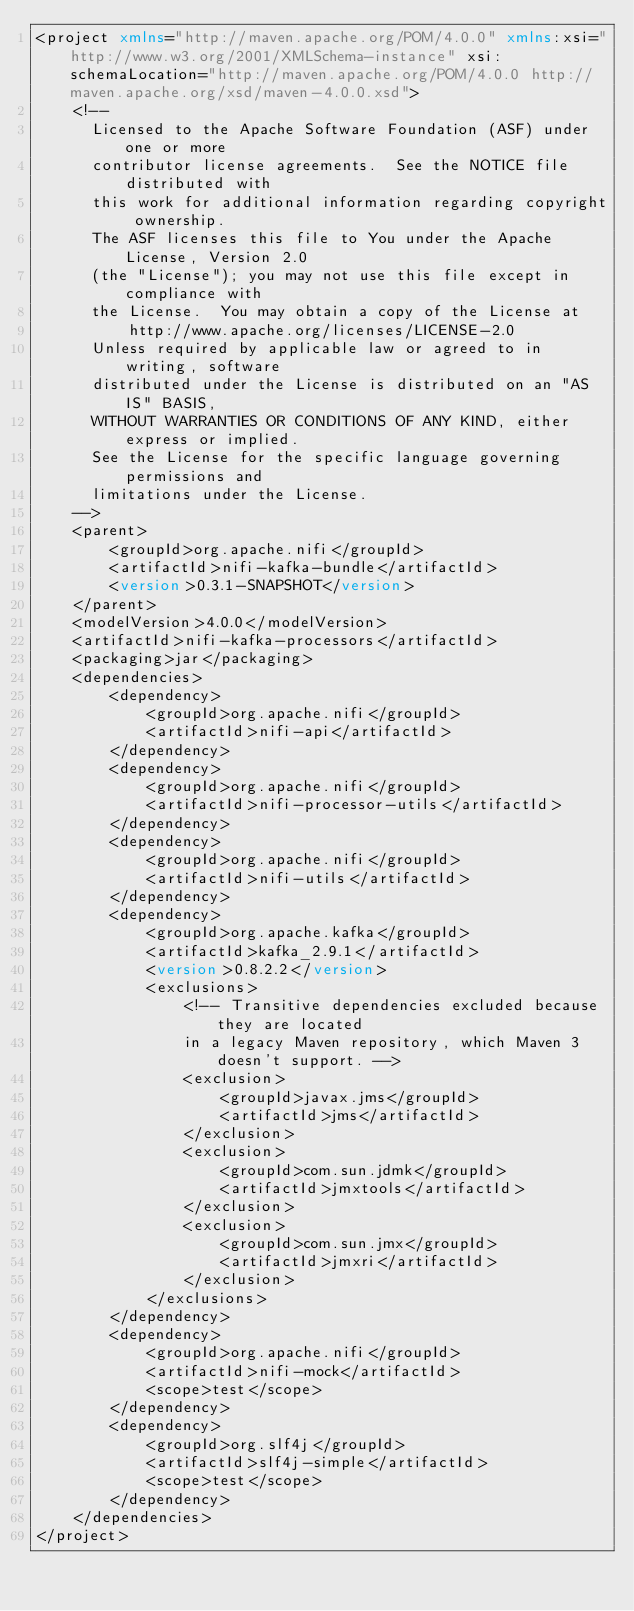Convert code to text. <code><loc_0><loc_0><loc_500><loc_500><_XML_><project xmlns="http://maven.apache.org/POM/4.0.0" xmlns:xsi="http://www.w3.org/2001/XMLSchema-instance" xsi:schemaLocation="http://maven.apache.org/POM/4.0.0 http://maven.apache.org/xsd/maven-4.0.0.xsd">
    <!--
      Licensed to the Apache Software Foundation (ASF) under one or more
      contributor license agreements.  See the NOTICE file distributed with
      this work for additional information regarding copyright ownership.
      The ASF licenses this file to You under the Apache License, Version 2.0
      (the "License"); you may not use this file except in compliance with
      the License.  You may obtain a copy of the License at
          http://www.apache.org/licenses/LICENSE-2.0
      Unless required by applicable law or agreed to in writing, software
      distributed under the License is distributed on an "AS IS" BASIS,
      WITHOUT WARRANTIES OR CONDITIONS OF ANY KIND, either express or implied.
      See the License for the specific language governing permissions and
      limitations under the License.
    -->
    <parent>
        <groupId>org.apache.nifi</groupId>
        <artifactId>nifi-kafka-bundle</artifactId>
        <version>0.3.1-SNAPSHOT</version>
    </parent>
    <modelVersion>4.0.0</modelVersion>
    <artifactId>nifi-kafka-processors</artifactId>
    <packaging>jar</packaging>  
    <dependencies>
        <dependency>
            <groupId>org.apache.nifi</groupId>
            <artifactId>nifi-api</artifactId>
        </dependency>
        <dependency>
            <groupId>org.apache.nifi</groupId>
            <artifactId>nifi-processor-utils</artifactId>
        </dependency>
        <dependency>
            <groupId>org.apache.nifi</groupId>
            <artifactId>nifi-utils</artifactId>
        </dependency>
        <dependency>
            <groupId>org.apache.kafka</groupId>
            <artifactId>kafka_2.9.1</artifactId>
            <version>0.8.2.2</version>
            <exclusions>
                <!-- Transitive dependencies excluded because they are located 
                in a legacy Maven repository, which Maven 3 doesn't support. -->
                <exclusion>
                    <groupId>javax.jms</groupId>
                    <artifactId>jms</artifactId>
                </exclusion>
                <exclusion>
                    <groupId>com.sun.jdmk</groupId>
                    <artifactId>jmxtools</artifactId>
                </exclusion>
                <exclusion>
                    <groupId>com.sun.jmx</groupId>
                    <artifactId>jmxri</artifactId>
                </exclusion>
            </exclusions>
        </dependency>
        <dependency>
            <groupId>org.apache.nifi</groupId>
            <artifactId>nifi-mock</artifactId>
            <scope>test</scope>
        </dependency>
        <dependency>
            <groupId>org.slf4j</groupId>
            <artifactId>slf4j-simple</artifactId>
            <scope>test</scope>
        </dependency>
    </dependencies>
</project>
</code> 